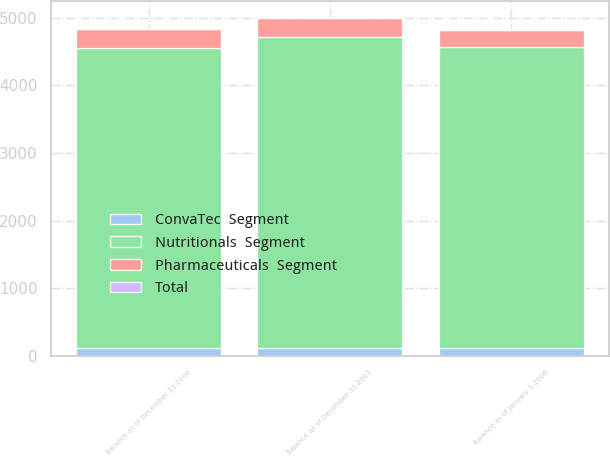Convert chart to OTSL. <chart><loc_0><loc_0><loc_500><loc_500><stacked_bar_chart><ecel><fcel>Balance as of January 1 2006<fcel>Balance as of December 31 2006<fcel>Balance as of December 31 2007<nl><fcel>Nutritionals  Segment<fcel>4448<fcel>4445<fcel>4603<nl><fcel>ConvaTec  Segment<fcel>113<fcel>113<fcel>113<nl><fcel>Pharmaceuticals  Segment<fcel>260<fcel>269<fcel>280<nl><fcel>Total<fcel>2<fcel>2<fcel>2<nl></chart> 